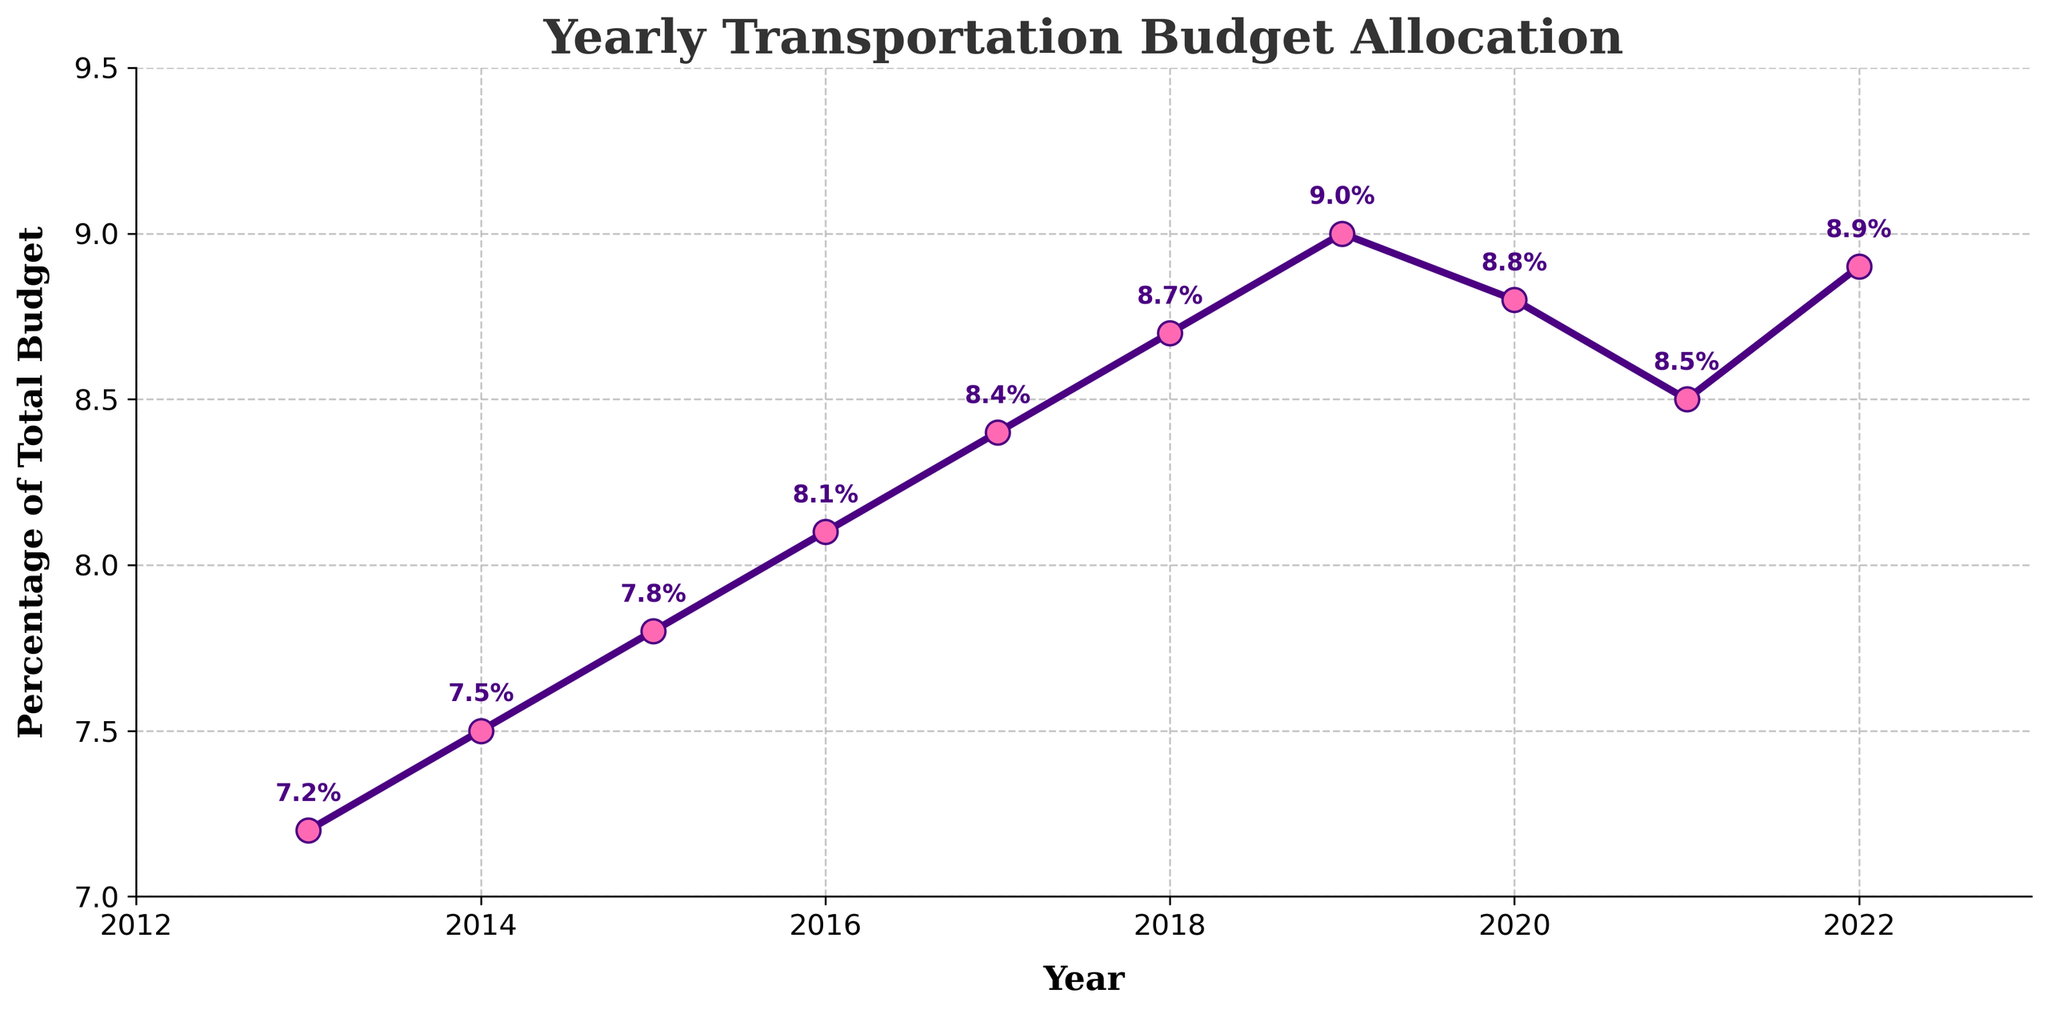What was the percentage spent on transportation in 2016? Looking at the data point for the year 2016, we see the corresponding value of 8.1%.
Answer: 8.1% Which year had the highest percentage spent on transportation? The highest point on the line chart corresponds to 2019, where the percentage reached 9.0%.
Answer: 2019 Between 2020 and 2021, did the transportation budget percentage increase or decrease? By observing the values for 2020 (8.8%) and 2021 (8.5%), it is clear there was a decrease.
Answer: Decrease What is the difference in transportation budget percentage between 2013 and 2022? The percentage in 2013 was 7.2% and in 2022 it was 8.9%. The difference is calculated as 8.9% - 7.2% = 1.7%.
Answer: 1.7% During which period did the transportation budget percentage decrease consecutively? By examining the trend, we see a consecutive decrease from 2019 (9.0%) to 2020 (8.8%) and then to 2021 (8.5%).
Answer: 2019 to 2021 On average, what was the percentage allocation for transportation from 2013 to 2022? Sum the percentages from 2013 to 2022, which is 7.2 + 7.5 + 7.8 + 8.1 + 8.4 + 8.7 + 9.0 + 8.8 + 8.5 + 8.9 = 82.9. Then, divide by the number of years, which is 10. 82.9 / 10 = 8.29%.
Answer: 8.29% Did the transportation budget percentage ever reach 9%? From the plot, the percentage reached 9.0% in 2019.
Answer: Yes What was the trend in the transportation budget percentage from 2013 to 2018? The plot shows a steady increase from 2013 (7.2%) to 2018 (8.7%).
Answer: Increase What color is used for the markers on the plot? The markers on the plot are pink.
Answer: Pink What percentage change occurred between the highest and lowest budget allocation points? The highest is 9.0% (2019) and the lowest is 7.2% (2013). The change can be calculated as 9.0% - 7.2% = 1.8%.
Answer: 1.8% 